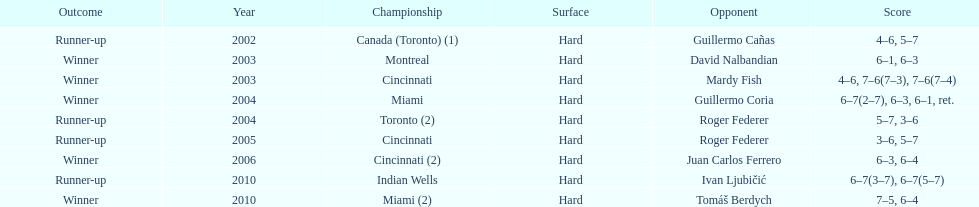How many times was roger federer a runner-up? 2. 